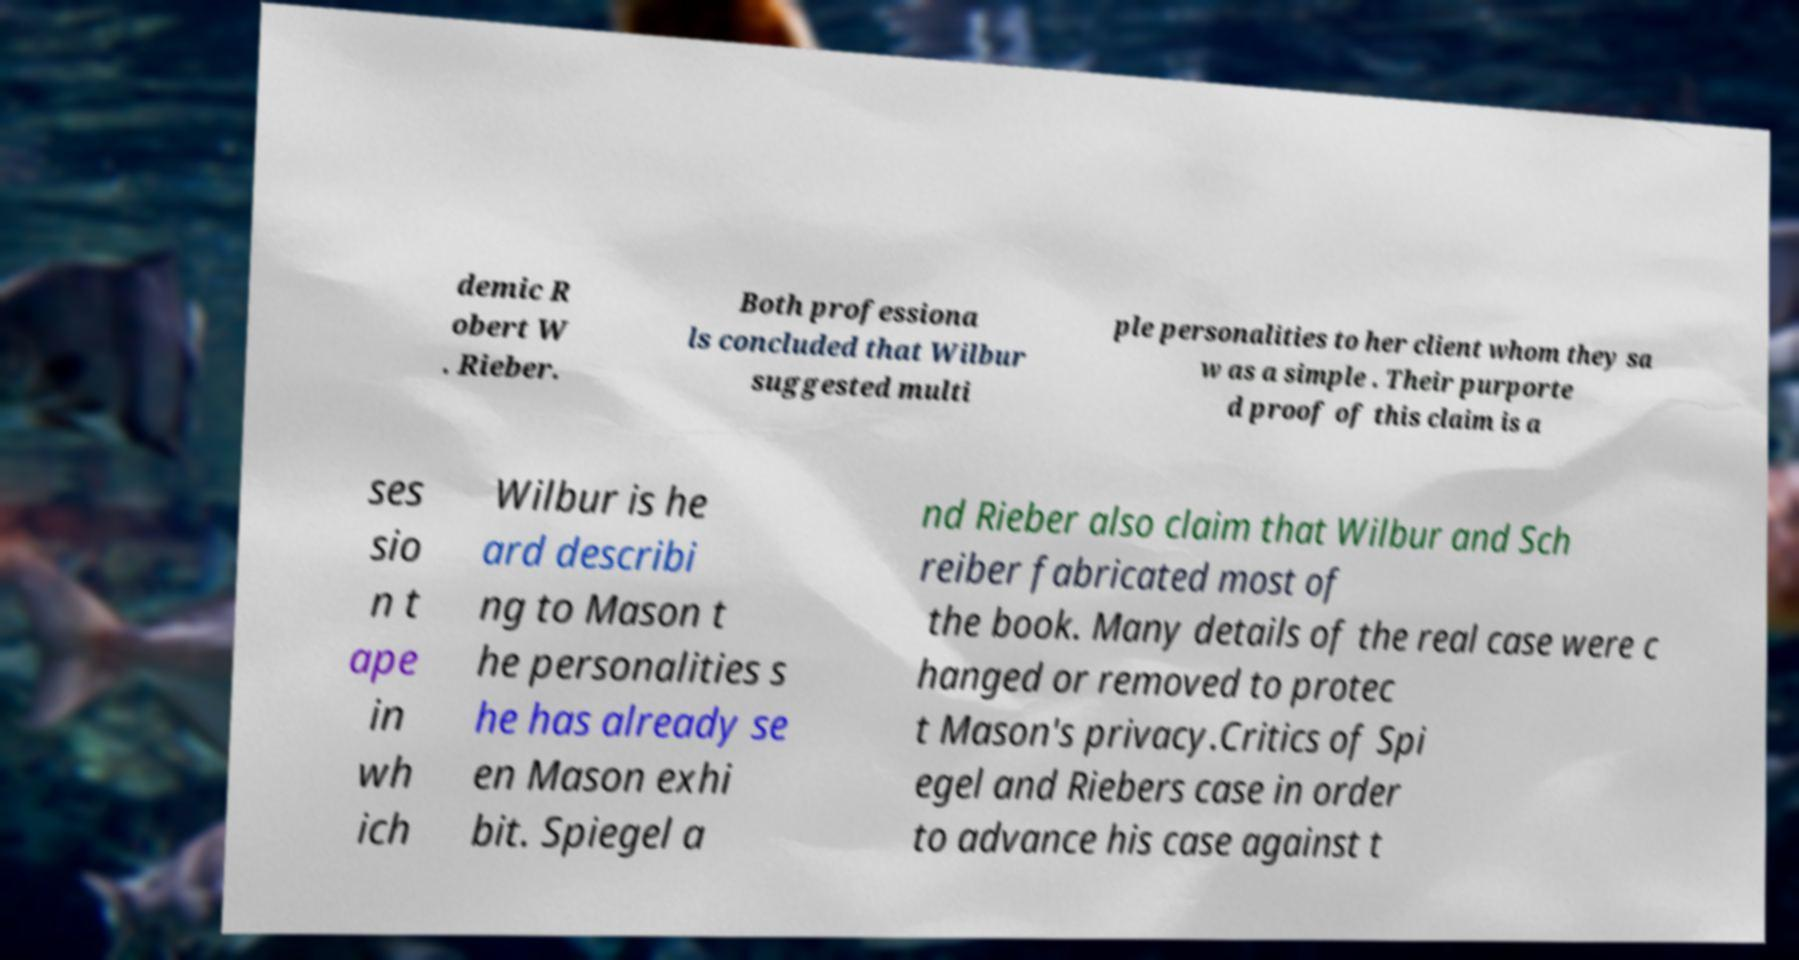What messages or text are displayed in this image? I need them in a readable, typed format. demic R obert W . Rieber. Both professiona ls concluded that Wilbur suggested multi ple personalities to her client whom they sa w as a simple . Their purporte d proof of this claim is a ses sio n t ape in wh ich Wilbur is he ard describi ng to Mason t he personalities s he has already se en Mason exhi bit. Spiegel a nd Rieber also claim that Wilbur and Sch reiber fabricated most of the book. Many details of the real case were c hanged or removed to protec t Mason's privacy.Critics of Spi egel and Riebers case in order to advance his case against t 